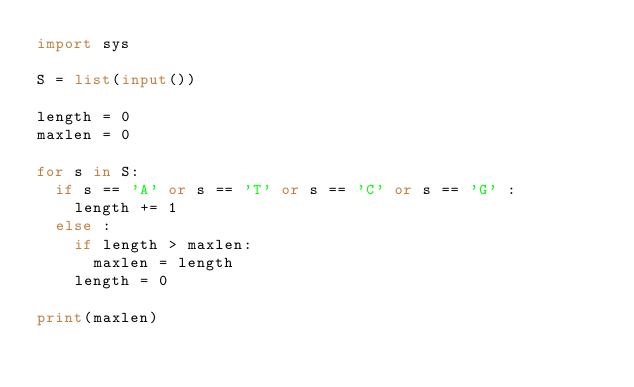Convert code to text. <code><loc_0><loc_0><loc_500><loc_500><_Python_>import sys

S = list(input())

length = 0
maxlen = 0

for s in S:
	if s == 'A' or s == 'T' or s == 'C' or s == 'G' :
		length += 1
	else :
		if length > maxlen:
			maxlen = length
		length = 0

print(maxlen)


</code> 